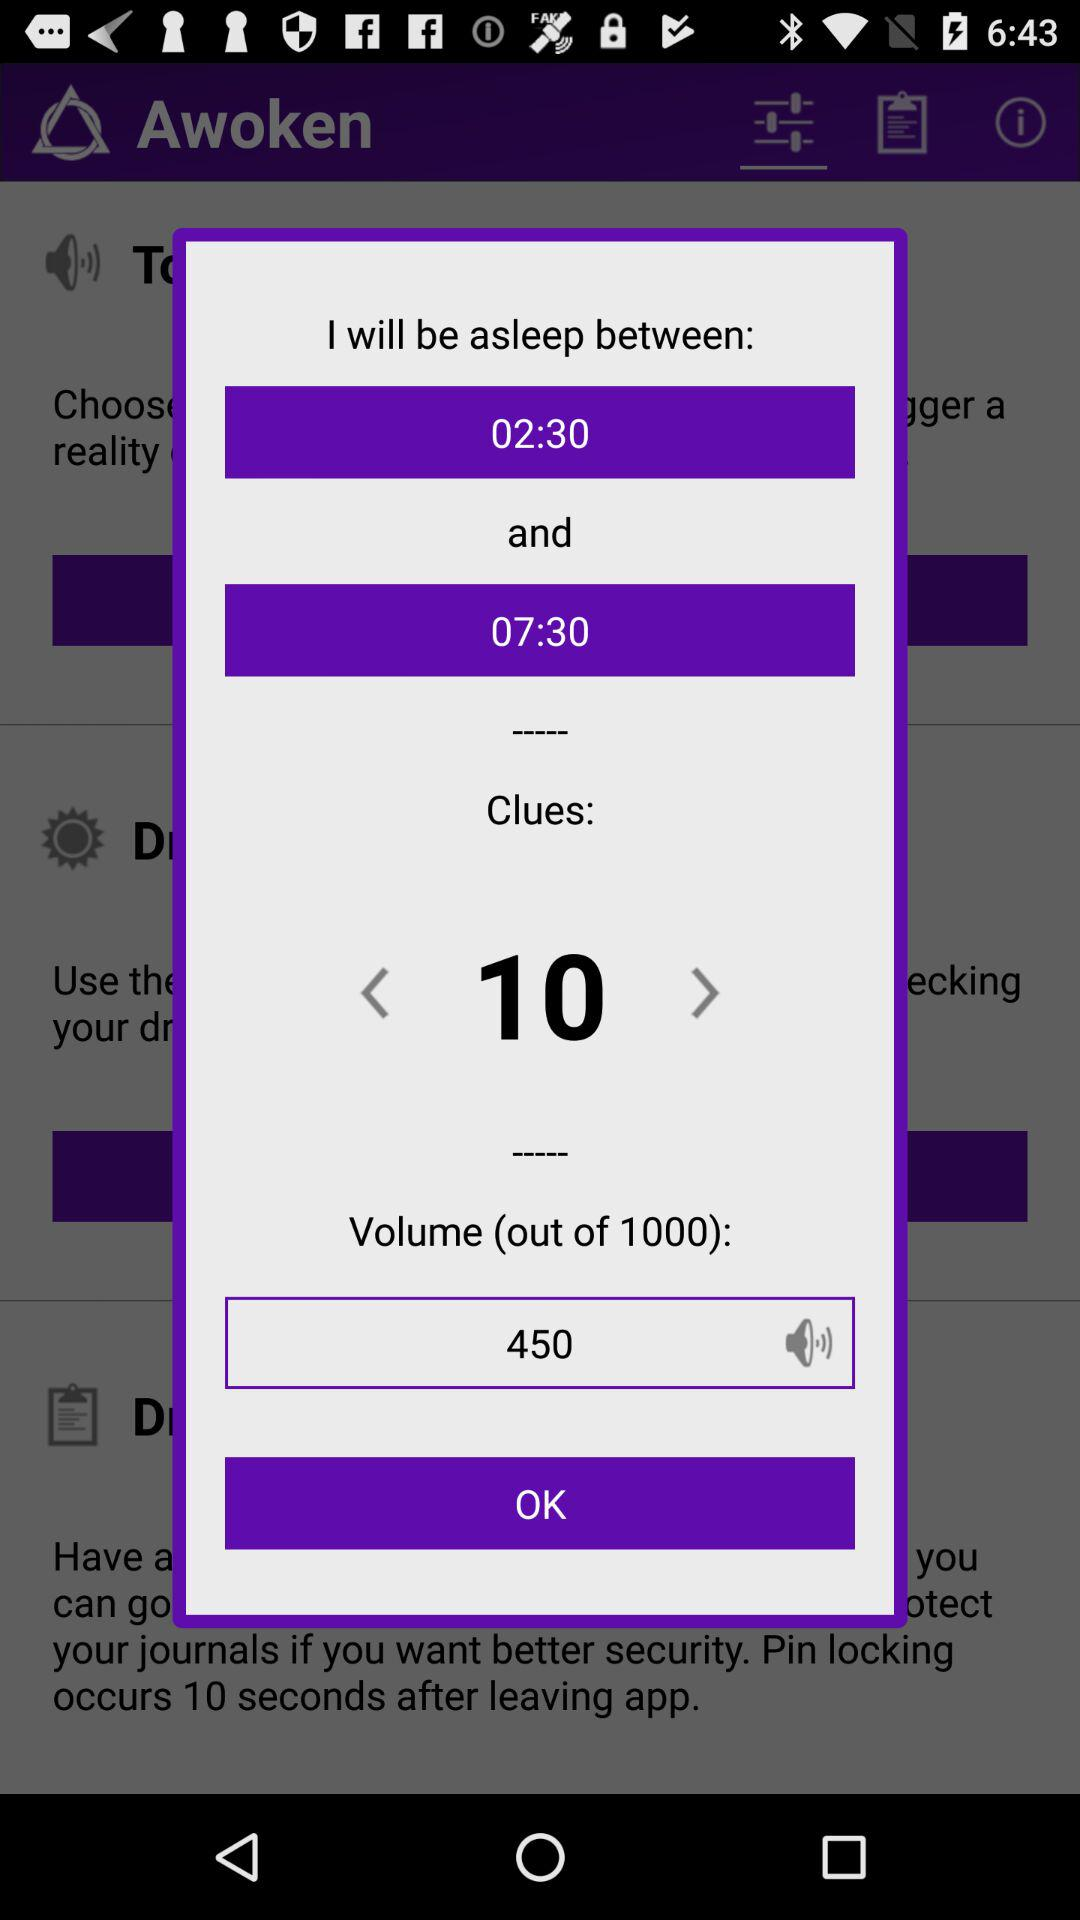How many hours are between the start and end time?
Answer the question using a single word or phrase. 5 